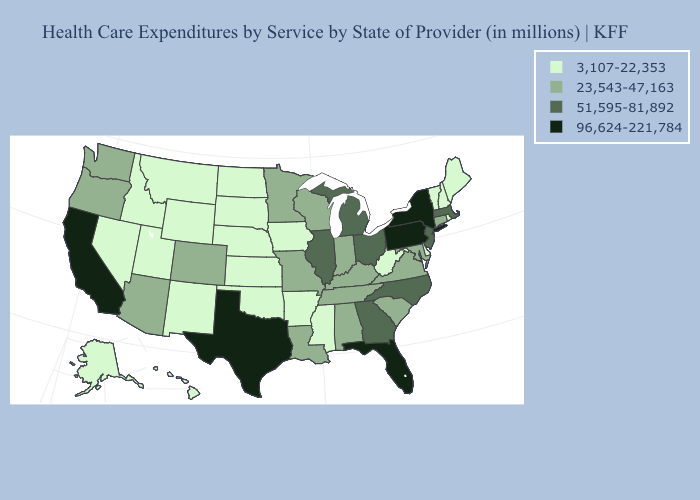Name the states that have a value in the range 3,107-22,353?
Answer briefly. Alaska, Arkansas, Delaware, Hawaii, Idaho, Iowa, Kansas, Maine, Mississippi, Montana, Nebraska, Nevada, New Hampshire, New Mexico, North Dakota, Oklahoma, Rhode Island, South Dakota, Utah, Vermont, West Virginia, Wyoming. What is the lowest value in the USA?
Quick response, please. 3,107-22,353. What is the lowest value in states that border Georgia?
Write a very short answer. 23,543-47,163. What is the lowest value in states that border North Carolina?
Concise answer only. 23,543-47,163. Does the first symbol in the legend represent the smallest category?
Keep it brief. Yes. What is the highest value in the West ?
Give a very brief answer. 96,624-221,784. Name the states that have a value in the range 96,624-221,784?
Concise answer only. California, Florida, New York, Pennsylvania, Texas. What is the lowest value in states that border Montana?
Concise answer only. 3,107-22,353. Does the first symbol in the legend represent the smallest category?
Be succinct. Yes. Name the states that have a value in the range 51,595-81,892?
Concise answer only. Georgia, Illinois, Massachusetts, Michigan, New Jersey, North Carolina, Ohio. What is the highest value in the USA?
Be succinct. 96,624-221,784. What is the value of North Dakota?
Short answer required. 3,107-22,353. What is the value of New Mexico?
Give a very brief answer. 3,107-22,353. What is the value of Nebraska?
Quick response, please. 3,107-22,353. What is the highest value in states that border South Dakota?
Be succinct. 23,543-47,163. 